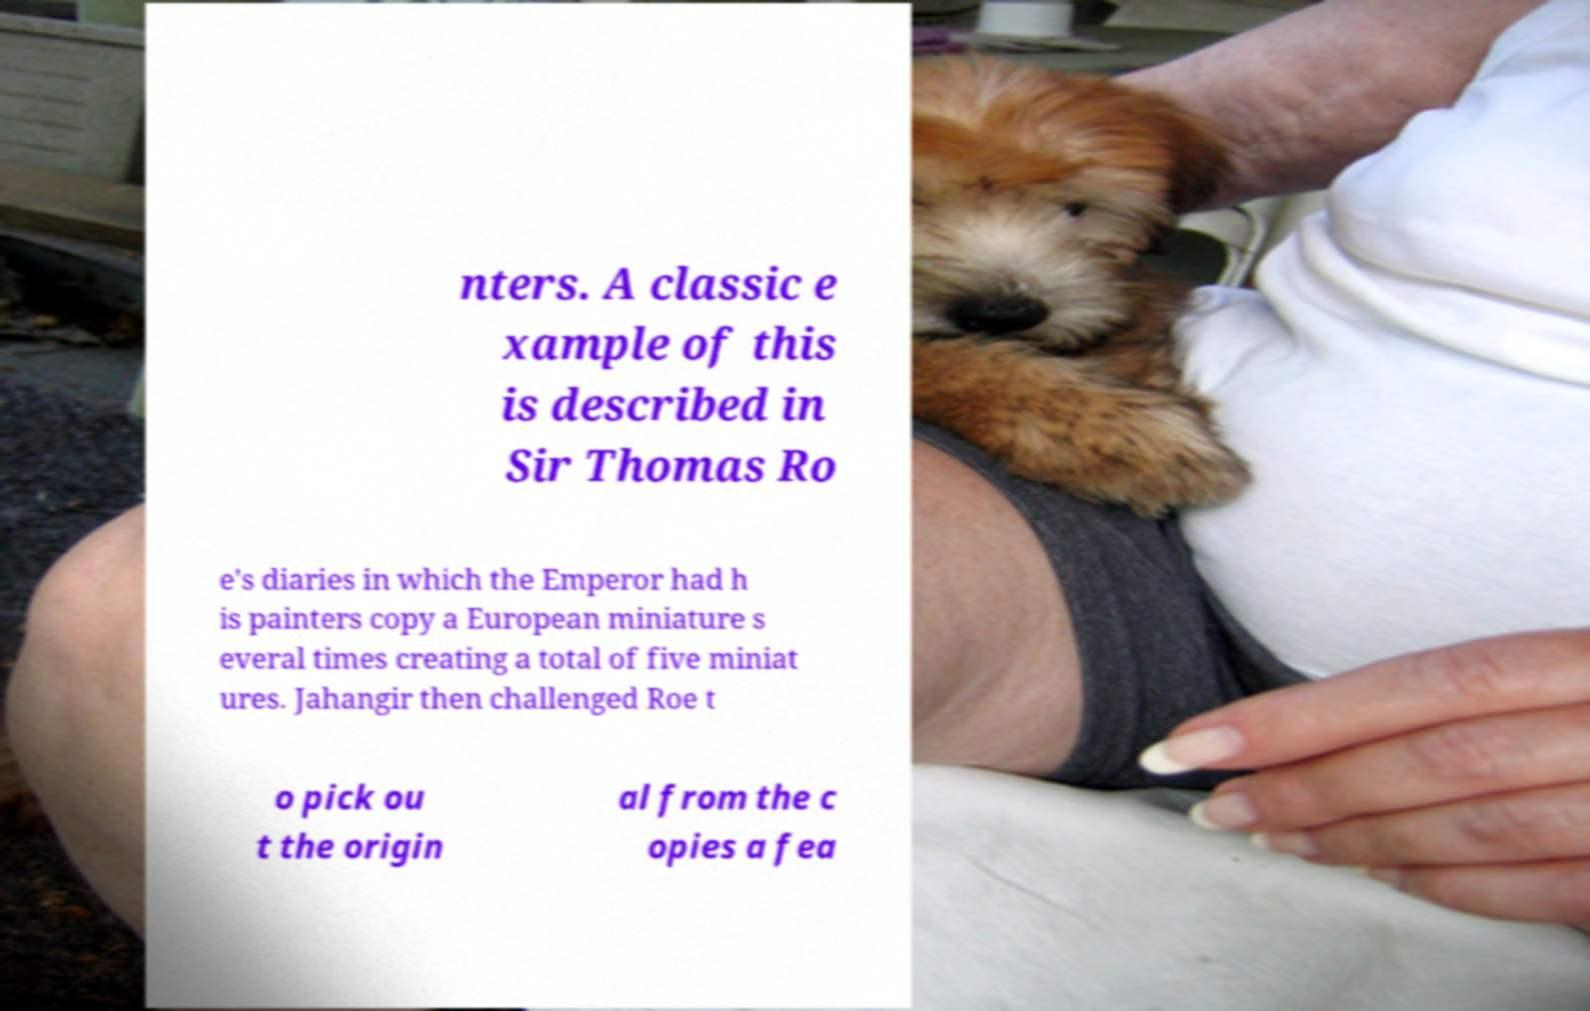Could you assist in decoding the text presented in this image and type it out clearly? nters. A classic e xample of this is described in Sir Thomas Ro e's diaries in which the Emperor had h is painters copy a European miniature s everal times creating a total of five miniat ures. Jahangir then challenged Roe t o pick ou t the origin al from the c opies a fea 